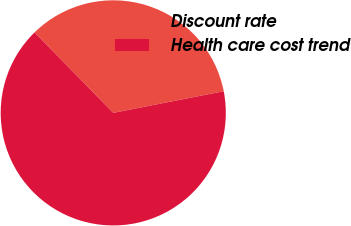Convert chart to OTSL. <chart><loc_0><loc_0><loc_500><loc_500><pie_chart><fcel>Discount rate<fcel>Health care cost trend<nl><fcel>34.24%<fcel>65.76%<nl></chart> 